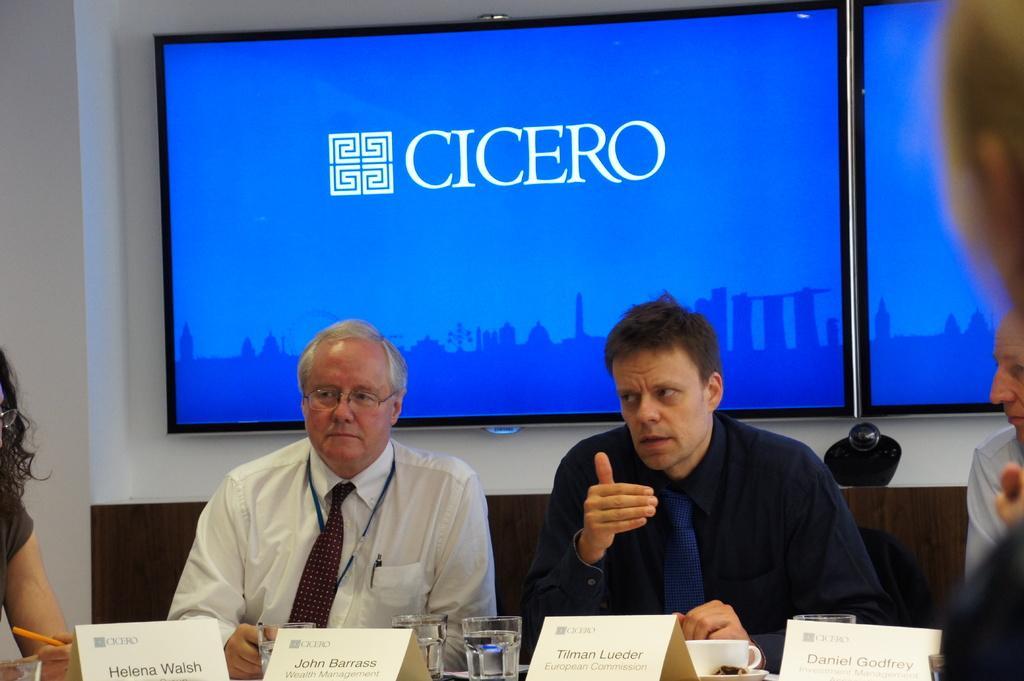How would you summarize this image in a sentence or two? In this picture there are people and we can see chairs. We can see name boards, glasses, cup and saucer on the platform. In the background of the image we can see screens on the wall. 